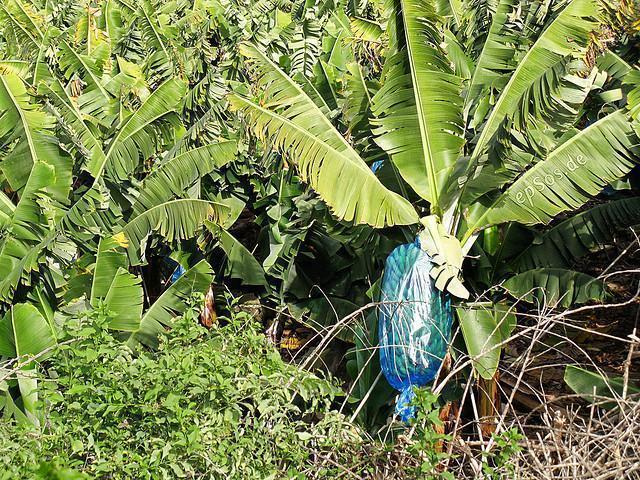What fruit is in the bright blue bag?
Pick the right solution, then justify: 'Answer: answer
Rationale: rationale.'
Options: Kiwis, bananas, jackfruit, plantains. Answer: bananas.
Rationale: The bananas ripen faster in the bag. 